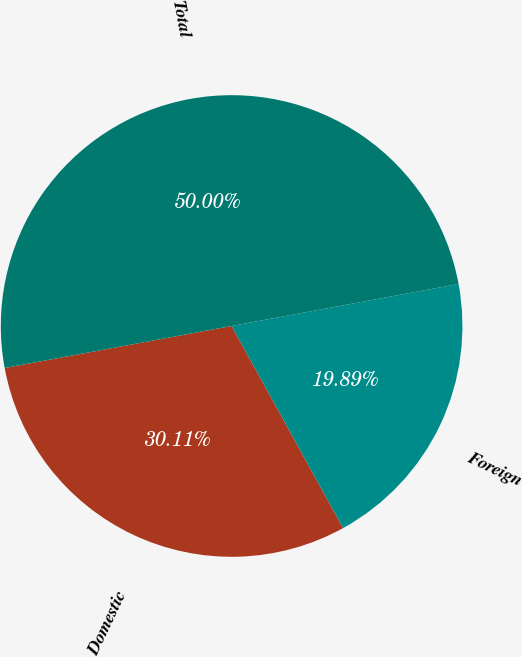Convert chart. <chart><loc_0><loc_0><loc_500><loc_500><pie_chart><fcel>Domestic<fcel>Foreign<fcel>Total<nl><fcel>30.11%<fcel>19.89%<fcel>50.0%<nl></chart> 